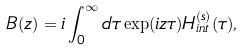Convert formula to latex. <formula><loc_0><loc_0><loc_500><loc_500>B ( z ) = i \int _ { 0 } ^ { \infty } d \tau \exp ( i z \tau ) H _ { i n t } ^ { ( s ) } ( \tau ) ,</formula> 